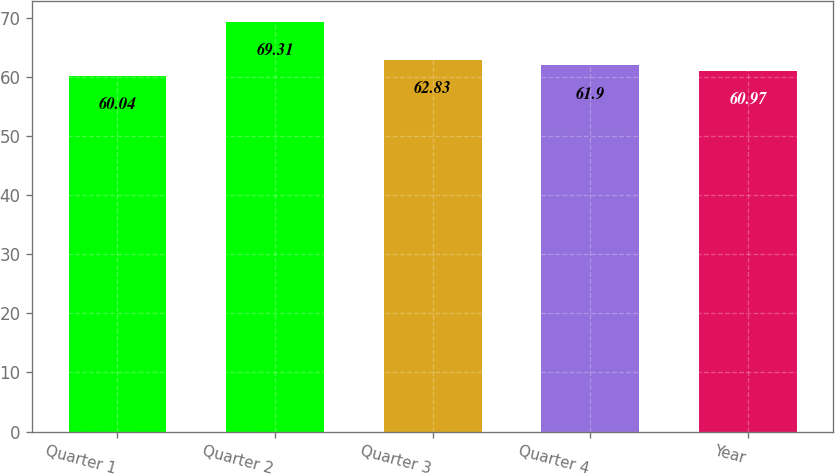Convert chart. <chart><loc_0><loc_0><loc_500><loc_500><bar_chart><fcel>Quarter 1<fcel>Quarter 2<fcel>Quarter 3<fcel>Quarter 4<fcel>Year<nl><fcel>60.04<fcel>69.31<fcel>62.83<fcel>61.9<fcel>60.97<nl></chart> 